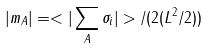Convert formula to latex. <formula><loc_0><loc_0><loc_500><loc_500>| m _ { A } | = < | \sum _ { A } { \sigma _ { i } } | > / ( 2 ( L ^ { 2 } / 2 ) )</formula> 